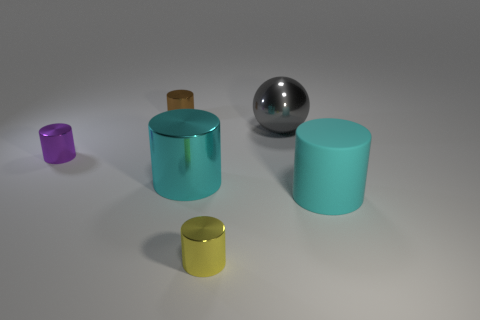Subtract all yellow cylinders. How many cylinders are left? 4 Subtract all purple cylinders. How many cylinders are left? 4 Subtract all green cylinders. Subtract all green cubes. How many cylinders are left? 5 Add 1 large green metallic objects. How many objects exist? 7 Subtract all spheres. How many objects are left? 5 Subtract all large green blocks. Subtract all gray objects. How many objects are left? 5 Add 3 big cyan things. How many big cyan things are left? 5 Add 3 small metal objects. How many small metal objects exist? 6 Subtract 0 yellow spheres. How many objects are left? 6 